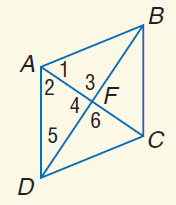Answer the mathemtical geometry problem and directly provide the correct option letter.
Question: Use rhombus A B C D with m \angle 1 = 2 x + 20, m \angle 2 = 5 x - 4, A C = 15, and m \angle 3 = y^ { 2 } + 26. Find A F.
Choices: A: 2.5 B: 5 C: 7.5 D: 10 C 